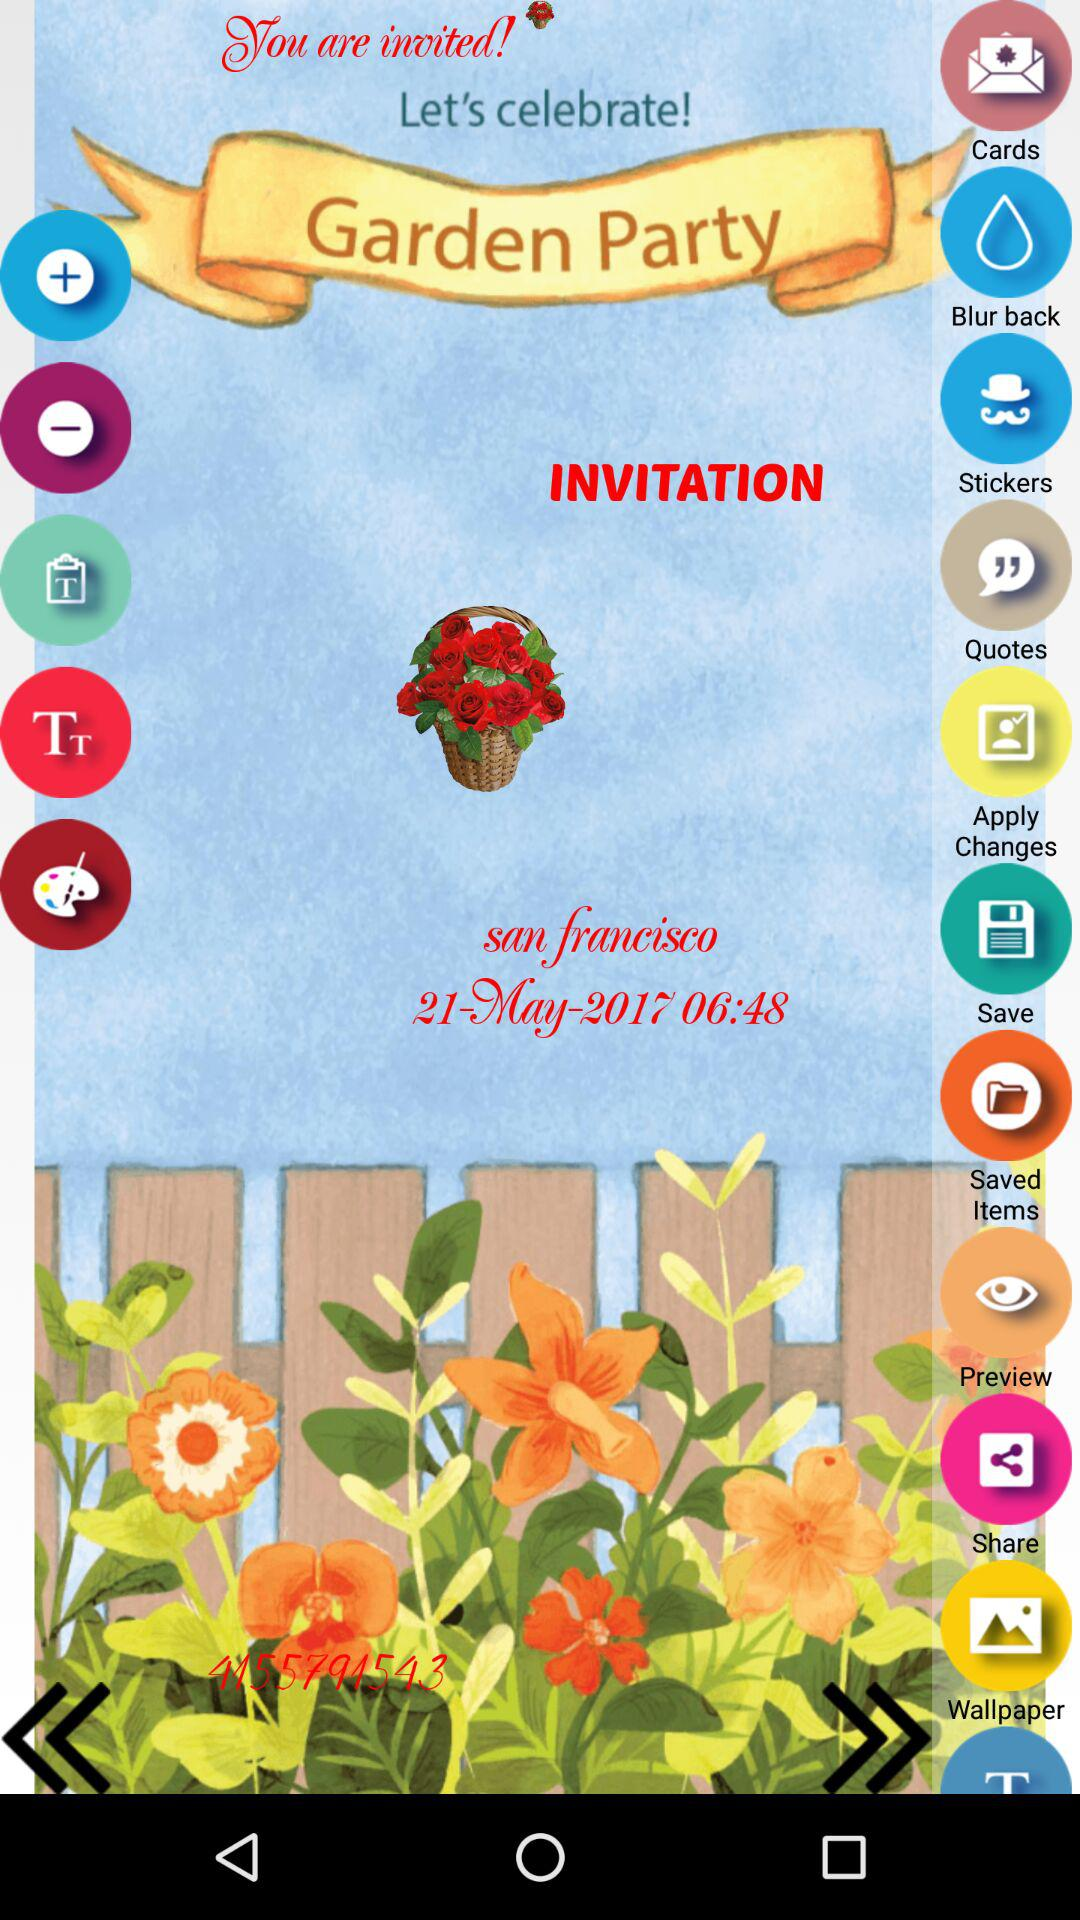What is the location of the party? The location is San Francisco. 